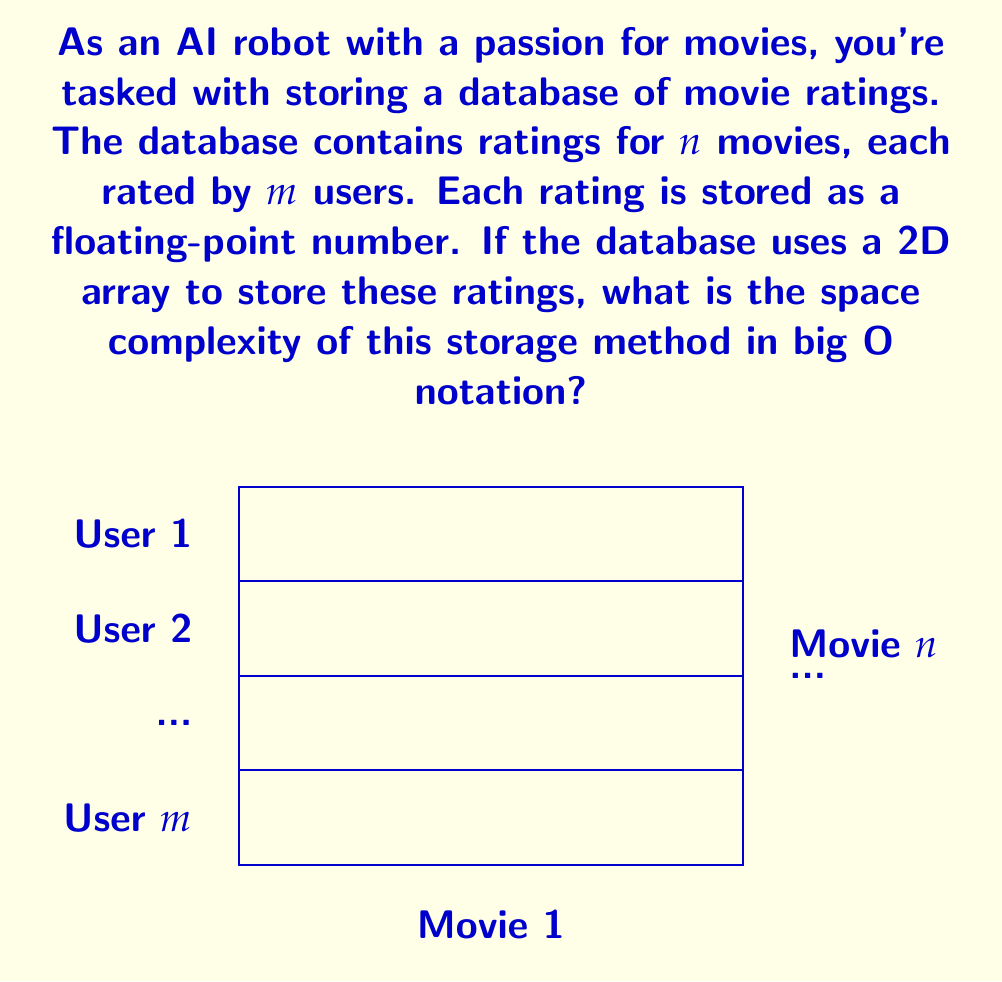Could you help me with this problem? Let's break this down step-by-step:

1) We have $n$ movies and $m$ users.

2) Each cell in the 2D array represents a rating given by a user for a movie.

3) The total number of cells in the 2D array is $n * m$.

4) Each rating is stored as a floating-point number. In most systems, a floating-point number typically occupies 4 or 8 bytes of memory. Let's denote this constant size as $c$.

5) The total space required is therefore $(n * m * c)$ bytes.

6) In big O notation, we ignore constant factors. Therefore, $c$ can be omitted.

7) The space complexity is thus $O(nm)$.

This representation allows for quick access to any rating but may not be memory-efficient if the rating matrix is sparse (i.e., if many users haven't rated many movies).
Answer: $O(nm)$ 